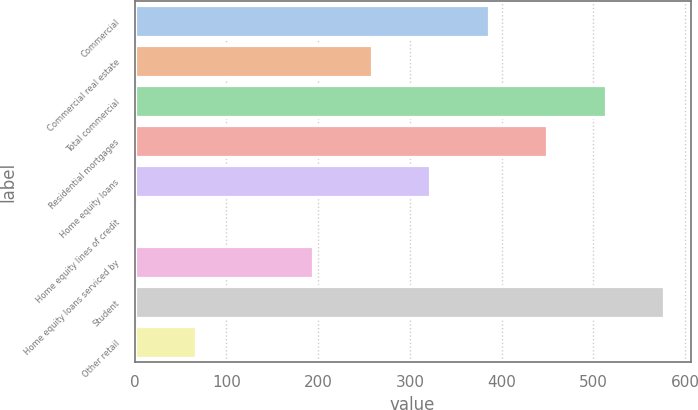Convert chart. <chart><loc_0><loc_0><loc_500><loc_500><bar_chart><fcel>Commercial<fcel>Commercial real estate<fcel>Total commercial<fcel>Residential mortgages<fcel>Home equity loans<fcel>Home equity lines of credit<fcel>Home equity loans serviced by<fcel>Student<fcel>Other retail<nl><fcel>385.8<fcel>258.2<fcel>513.4<fcel>449.6<fcel>322<fcel>3<fcel>194.4<fcel>577.2<fcel>66.8<nl></chart> 